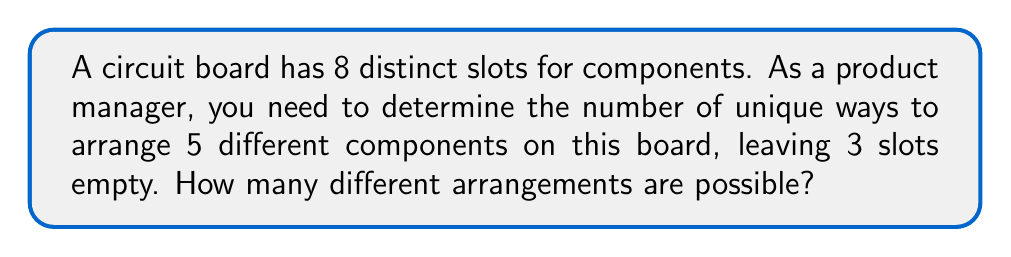Give your solution to this math problem. Let's approach this step-by-step:

1) First, we need to choose which 5 slots out of the 8 will be filled. This is a combination problem, represented as $\binom{8}{5}$.

   $$\binom{8}{5} = \frac{8!}{5!(8-5)!} = \frac{8!}{5!3!} = 56$$

2) Once we've chosen the 5 slots, we need to arrange the 5 components in these slots. This is a permutation of 5 objects, which is simply 5!.

   $$5! = 5 \times 4 \times 3 \times 2 \times 1 = 120$$

3) By the multiplication principle, the total number of ways to arrange the components is the product of these two numbers:

   $$56 \times 120 = 6,720$$

This calculation combines:
- The number of ways to choose 5 slots out of 8 (combination)
- The number of ways to arrange 5 components in those 5 slots (permutation)
Answer: 6,720 